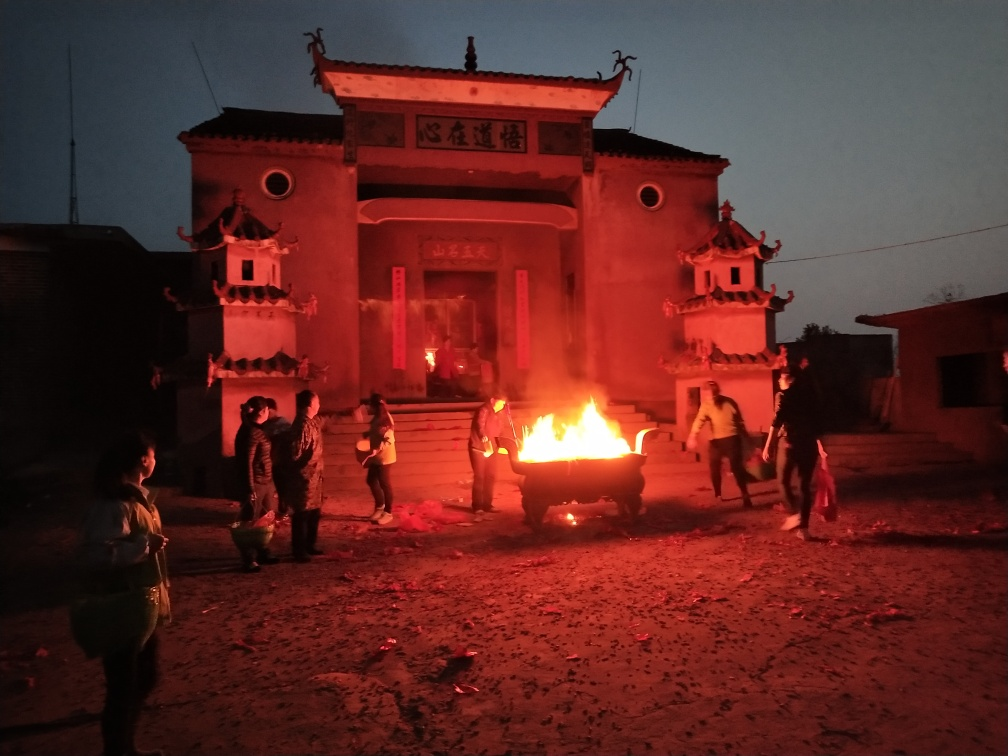How would you rate the details in this image? A. extremely detailed B. vague C. lacking D. average Answer with the option's letter from the given choices directly. D. The image offers an average level of detail. It provides a clear view of the scene featuring individuals gathered around a fire in front of a building, possibly indicative of a community event or a ritual. While the finer details of the individuals' expressions and the building's textures are not crisp due to the lighting conditions, there is enough visual information to interpret the basic activities and setting. 